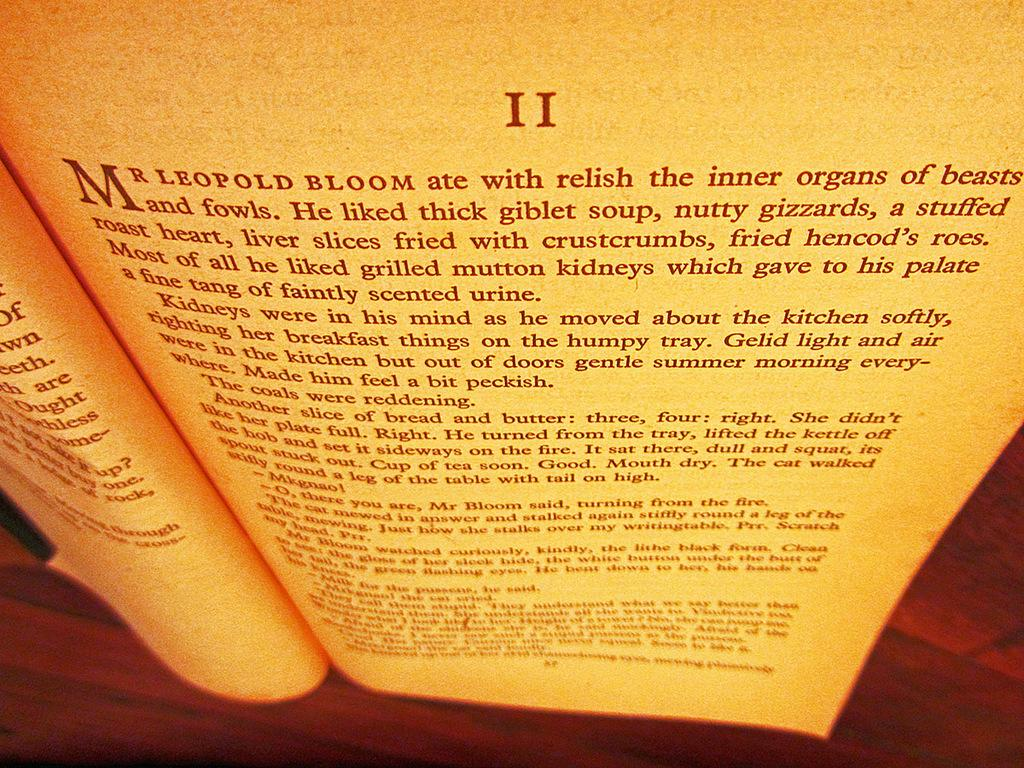Provide a one-sentence caption for the provided image. Mr LEOPOLD BLOOM ate with relish is written on the page. 